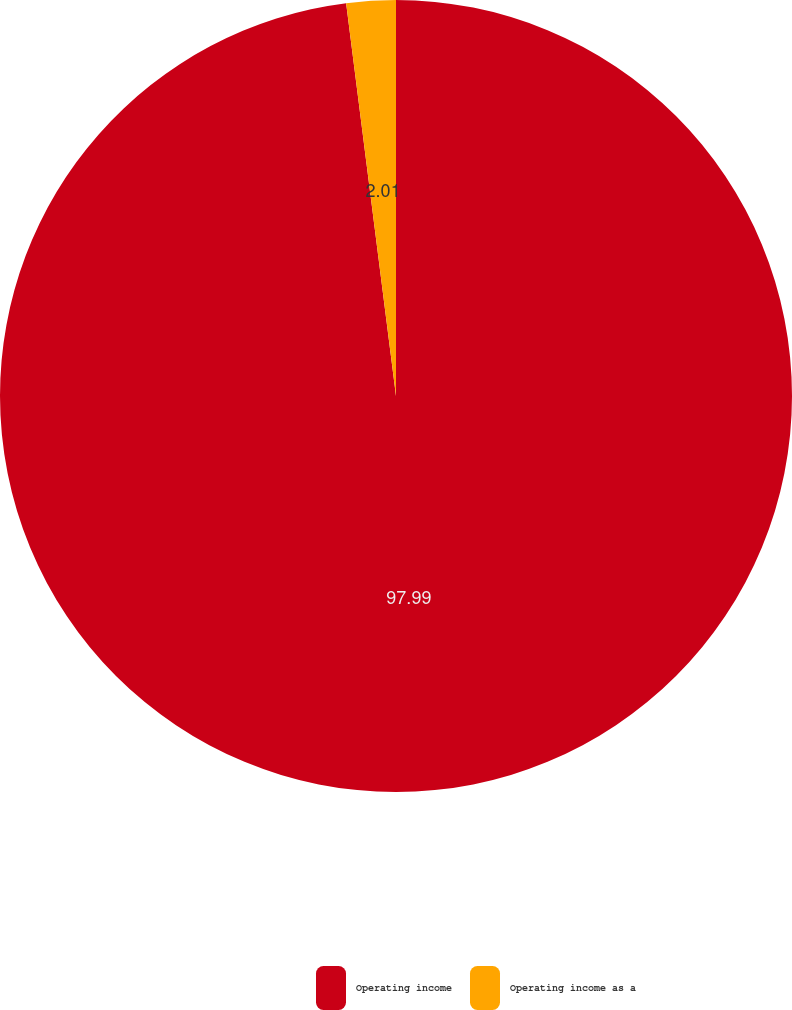Convert chart to OTSL. <chart><loc_0><loc_0><loc_500><loc_500><pie_chart><fcel>Operating income<fcel>Operating income as a<nl><fcel>97.99%<fcel>2.01%<nl></chart> 